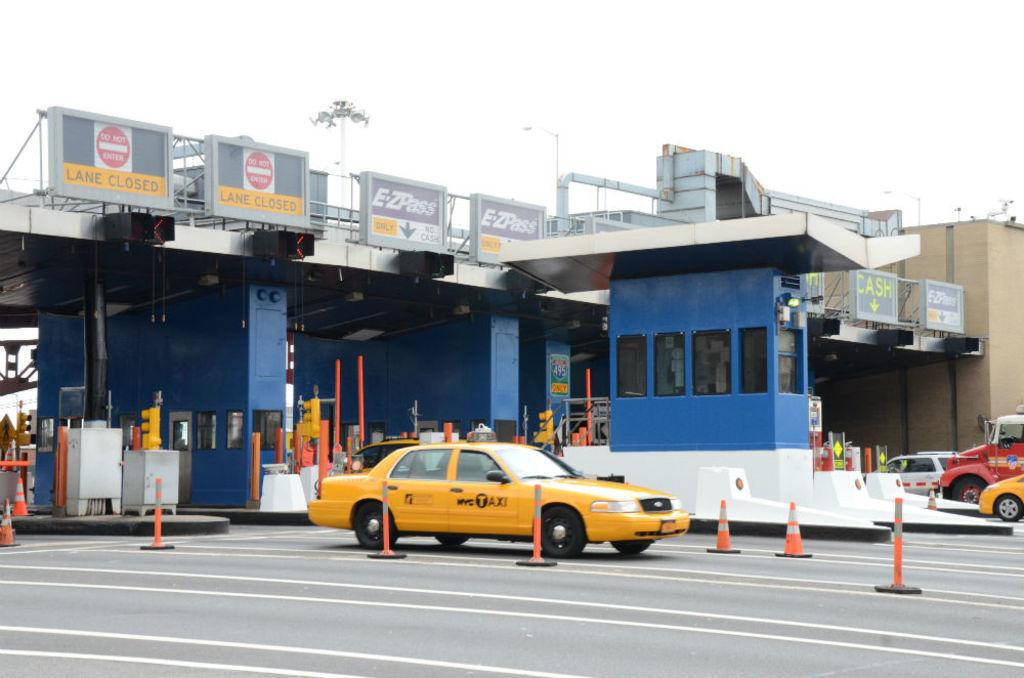<image>
Provide a brief description of the given image. A yellow car that says NYC Taxi is driving past a border crossing. 